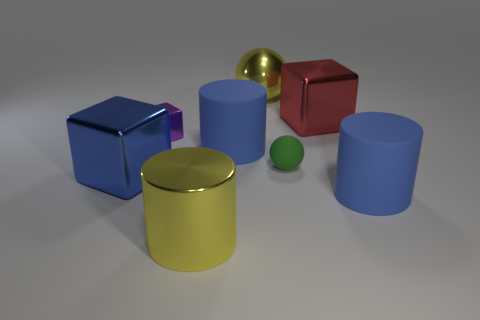How many other things are the same material as the green sphere?
Your answer should be compact. 2. Is there a large green matte thing?
Your response must be concise. No. Are there the same number of large things in front of the large sphere and small gray cylinders?
Your response must be concise. No. What number of other things are there of the same shape as the purple thing?
Offer a very short reply. 2. The red metallic thing has what shape?
Provide a succinct answer. Cube. Is the material of the green ball the same as the large blue block?
Offer a terse response. No. Is the number of purple metallic blocks that are in front of the large blue shiny thing the same as the number of large red metal things that are in front of the yellow cylinder?
Your answer should be very brief. Yes. There is a large yellow object that is to the right of the blue cylinder that is left of the red metal block; are there any blue shiny blocks that are to the right of it?
Give a very brief answer. No. Is the green rubber sphere the same size as the red object?
Make the answer very short. No. The big metal thing on the right side of the yellow shiny thing right of the large yellow metal thing that is in front of the big blue shiny cube is what color?
Your answer should be very brief. Red. 